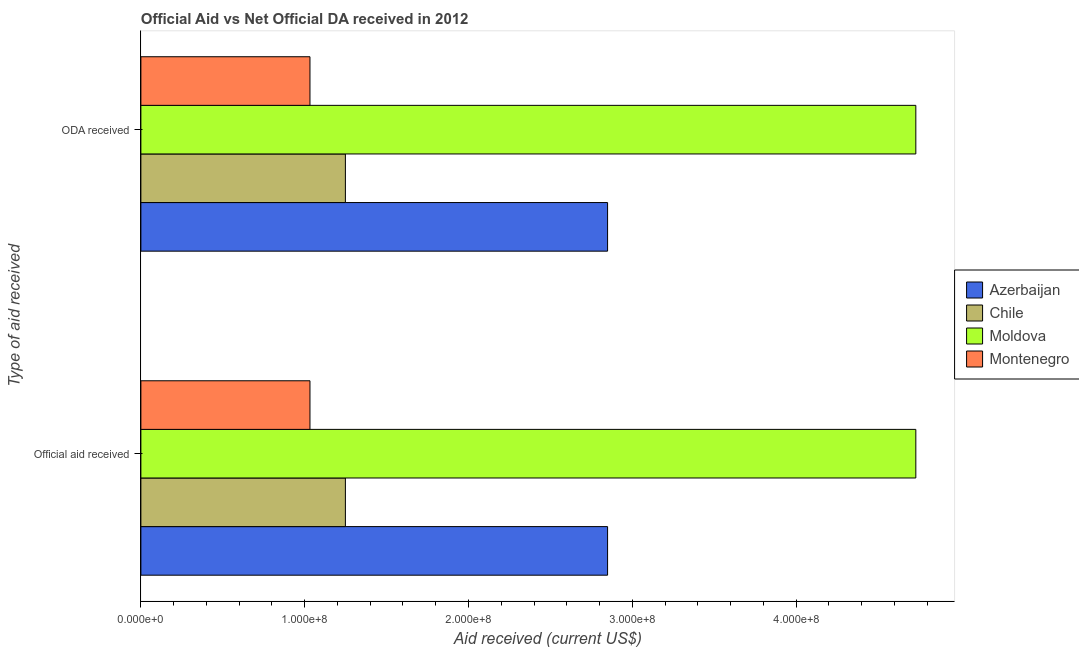How many groups of bars are there?
Your answer should be compact. 2. What is the label of the 2nd group of bars from the top?
Provide a short and direct response. Official aid received. What is the official aid received in Montenegro?
Your response must be concise. 1.03e+08. Across all countries, what is the maximum oda received?
Make the answer very short. 4.73e+08. Across all countries, what is the minimum oda received?
Your response must be concise. 1.03e+08. In which country was the official aid received maximum?
Your answer should be compact. Moldova. In which country was the official aid received minimum?
Your response must be concise. Montenegro. What is the total official aid received in the graph?
Ensure brevity in your answer.  9.86e+08. What is the difference between the official aid received in Chile and that in Azerbaijan?
Provide a short and direct response. -1.60e+08. What is the difference between the official aid received in Montenegro and the oda received in Azerbaijan?
Your response must be concise. -1.82e+08. What is the average official aid received per country?
Your answer should be very brief. 2.47e+08. What is the difference between the official aid received and oda received in Azerbaijan?
Give a very brief answer. 0. In how many countries, is the official aid received greater than 400000000 US$?
Make the answer very short. 1. What is the ratio of the oda received in Moldova to that in Montenegro?
Ensure brevity in your answer.  4.58. Is the official aid received in Moldova less than that in Azerbaijan?
Provide a short and direct response. No. In how many countries, is the oda received greater than the average oda received taken over all countries?
Ensure brevity in your answer.  2. What does the 1st bar from the bottom in ODA received represents?
Offer a terse response. Azerbaijan. Are all the bars in the graph horizontal?
Your answer should be compact. Yes. How many countries are there in the graph?
Offer a very short reply. 4. Are the values on the major ticks of X-axis written in scientific E-notation?
Your answer should be very brief. Yes. Does the graph contain any zero values?
Provide a short and direct response. No. Where does the legend appear in the graph?
Offer a terse response. Center right. What is the title of the graph?
Your answer should be compact. Official Aid vs Net Official DA received in 2012 . Does "Zimbabwe" appear as one of the legend labels in the graph?
Ensure brevity in your answer.  No. What is the label or title of the X-axis?
Your answer should be very brief. Aid received (current US$). What is the label or title of the Y-axis?
Make the answer very short. Type of aid received. What is the Aid received (current US$) in Azerbaijan in Official aid received?
Offer a terse response. 2.85e+08. What is the Aid received (current US$) of Chile in Official aid received?
Offer a terse response. 1.25e+08. What is the Aid received (current US$) in Moldova in Official aid received?
Ensure brevity in your answer.  4.73e+08. What is the Aid received (current US$) of Montenegro in Official aid received?
Ensure brevity in your answer.  1.03e+08. What is the Aid received (current US$) in Azerbaijan in ODA received?
Your answer should be very brief. 2.85e+08. What is the Aid received (current US$) of Chile in ODA received?
Ensure brevity in your answer.  1.25e+08. What is the Aid received (current US$) in Moldova in ODA received?
Make the answer very short. 4.73e+08. What is the Aid received (current US$) of Montenegro in ODA received?
Make the answer very short. 1.03e+08. Across all Type of aid received, what is the maximum Aid received (current US$) of Azerbaijan?
Make the answer very short. 2.85e+08. Across all Type of aid received, what is the maximum Aid received (current US$) in Chile?
Offer a very short reply. 1.25e+08. Across all Type of aid received, what is the maximum Aid received (current US$) in Moldova?
Provide a short and direct response. 4.73e+08. Across all Type of aid received, what is the maximum Aid received (current US$) of Montenegro?
Offer a terse response. 1.03e+08. Across all Type of aid received, what is the minimum Aid received (current US$) in Azerbaijan?
Provide a short and direct response. 2.85e+08. Across all Type of aid received, what is the minimum Aid received (current US$) of Chile?
Ensure brevity in your answer.  1.25e+08. Across all Type of aid received, what is the minimum Aid received (current US$) of Moldova?
Ensure brevity in your answer.  4.73e+08. Across all Type of aid received, what is the minimum Aid received (current US$) in Montenegro?
Your answer should be compact. 1.03e+08. What is the total Aid received (current US$) of Azerbaijan in the graph?
Make the answer very short. 5.70e+08. What is the total Aid received (current US$) of Chile in the graph?
Offer a very short reply. 2.50e+08. What is the total Aid received (current US$) in Moldova in the graph?
Give a very brief answer. 9.46e+08. What is the total Aid received (current US$) of Montenegro in the graph?
Make the answer very short. 2.06e+08. What is the difference between the Aid received (current US$) of Azerbaijan in Official aid received and that in ODA received?
Your response must be concise. 0. What is the difference between the Aid received (current US$) of Chile in Official aid received and that in ODA received?
Give a very brief answer. 0. What is the difference between the Aid received (current US$) of Moldova in Official aid received and that in ODA received?
Give a very brief answer. 0. What is the difference between the Aid received (current US$) of Montenegro in Official aid received and that in ODA received?
Keep it short and to the point. 0. What is the difference between the Aid received (current US$) of Azerbaijan in Official aid received and the Aid received (current US$) of Chile in ODA received?
Keep it short and to the point. 1.60e+08. What is the difference between the Aid received (current US$) of Azerbaijan in Official aid received and the Aid received (current US$) of Moldova in ODA received?
Make the answer very short. -1.88e+08. What is the difference between the Aid received (current US$) of Azerbaijan in Official aid received and the Aid received (current US$) of Montenegro in ODA received?
Give a very brief answer. 1.82e+08. What is the difference between the Aid received (current US$) of Chile in Official aid received and the Aid received (current US$) of Moldova in ODA received?
Provide a short and direct response. -3.48e+08. What is the difference between the Aid received (current US$) in Chile in Official aid received and the Aid received (current US$) in Montenegro in ODA received?
Offer a very short reply. 2.16e+07. What is the difference between the Aid received (current US$) in Moldova in Official aid received and the Aid received (current US$) in Montenegro in ODA received?
Your answer should be compact. 3.70e+08. What is the average Aid received (current US$) of Azerbaijan per Type of aid received?
Your answer should be very brief. 2.85e+08. What is the average Aid received (current US$) in Chile per Type of aid received?
Provide a short and direct response. 1.25e+08. What is the average Aid received (current US$) of Moldova per Type of aid received?
Your answer should be very brief. 4.73e+08. What is the average Aid received (current US$) in Montenegro per Type of aid received?
Keep it short and to the point. 1.03e+08. What is the difference between the Aid received (current US$) in Azerbaijan and Aid received (current US$) in Chile in Official aid received?
Give a very brief answer. 1.60e+08. What is the difference between the Aid received (current US$) in Azerbaijan and Aid received (current US$) in Moldova in Official aid received?
Keep it short and to the point. -1.88e+08. What is the difference between the Aid received (current US$) of Azerbaijan and Aid received (current US$) of Montenegro in Official aid received?
Make the answer very short. 1.82e+08. What is the difference between the Aid received (current US$) in Chile and Aid received (current US$) in Moldova in Official aid received?
Offer a very short reply. -3.48e+08. What is the difference between the Aid received (current US$) in Chile and Aid received (current US$) in Montenegro in Official aid received?
Make the answer very short. 2.16e+07. What is the difference between the Aid received (current US$) in Moldova and Aid received (current US$) in Montenegro in Official aid received?
Ensure brevity in your answer.  3.70e+08. What is the difference between the Aid received (current US$) of Azerbaijan and Aid received (current US$) of Chile in ODA received?
Provide a short and direct response. 1.60e+08. What is the difference between the Aid received (current US$) in Azerbaijan and Aid received (current US$) in Moldova in ODA received?
Offer a terse response. -1.88e+08. What is the difference between the Aid received (current US$) in Azerbaijan and Aid received (current US$) in Montenegro in ODA received?
Keep it short and to the point. 1.82e+08. What is the difference between the Aid received (current US$) in Chile and Aid received (current US$) in Moldova in ODA received?
Offer a very short reply. -3.48e+08. What is the difference between the Aid received (current US$) of Chile and Aid received (current US$) of Montenegro in ODA received?
Offer a terse response. 2.16e+07. What is the difference between the Aid received (current US$) in Moldova and Aid received (current US$) in Montenegro in ODA received?
Make the answer very short. 3.70e+08. What is the ratio of the Aid received (current US$) of Azerbaijan in Official aid received to that in ODA received?
Provide a short and direct response. 1. What is the ratio of the Aid received (current US$) of Chile in Official aid received to that in ODA received?
Provide a short and direct response. 1. What is the ratio of the Aid received (current US$) of Moldova in Official aid received to that in ODA received?
Give a very brief answer. 1. What is the ratio of the Aid received (current US$) of Montenegro in Official aid received to that in ODA received?
Offer a very short reply. 1. What is the difference between the highest and the second highest Aid received (current US$) of Azerbaijan?
Your answer should be compact. 0. What is the difference between the highest and the second highest Aid received (current US$) of Chile?
Make the answer very short. 0. What is the difference between the highest and the second highest Aid received (current US$) in Moldova?
Your answer should be compact. 0. What is the difference between the highest and the lowest Aid received (current US$) in Azerbaijan?
Your answer should be very brief. 0. 